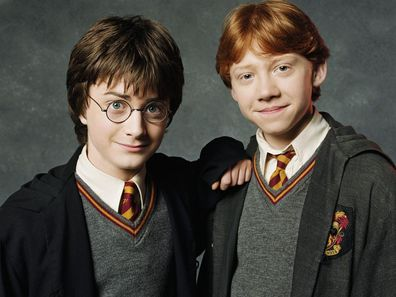Create a haiku inspired by this image. Gryffindor robes sway,
Two friends in magic's embrace,
Stars shine in their eyes. 